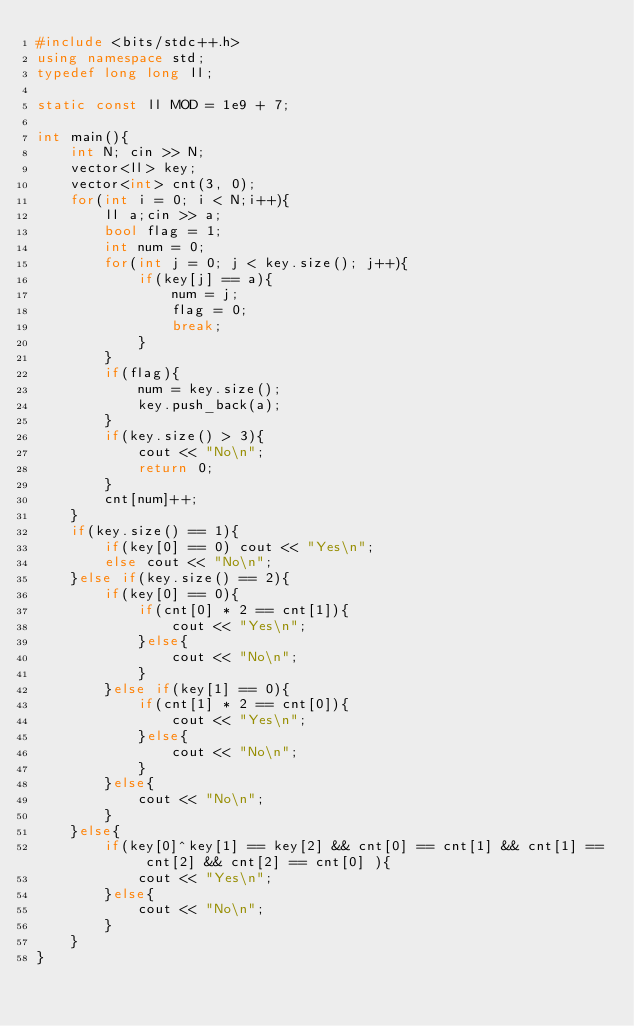<code> <loc_0><loc_0><loc_500><loc_500><_C++_>#include <bits/stdc++.h>
using namespace std;
typedef long long ll;

static const ll MOD = 1e9 + 7;

int main(){
    int N; cin >> N;
    vector<ll> key;
    vector<int> cnt(3, 0);
    for(int i = 0; i < N;i++){
        ll a;cin >> a;
        bool flag = 1;
        int num = 0;
        for(int j = 0; j < key.size(); j++){
            if(key[j] == a){
                num = j;
                flag = 0;
                break;
            }
        }
        if(flag){
            num = key.size();
            key.push_back(a);
        }
        if(key.size() > 3){
            cout << "No\n";
            return 0;
        }
        cnt[num]++;
    }
    if(key.size() == 1){
        if(key[0] == 0) cout << "Yes\n";
        else cout << "No\n";
    }else if(key.size() == 2){
        if(key[0] == 0){
            if(cnt[0] * 2 == cnt[1]){
                cout << "Yes\n";
            }else{
                cout << "No\n";
            }
        }else if(key[1] == 0){
            if(cnt[1] * 2 == cnt[0]){
                cout << "Yes\n";
            }else{
                cout << "No\n";
            }
        }else{
            cout << "No\n";
        }
    }else{
        if(key[0]^key[1] == key[2] && cnt[0] == cnt[1] && cnt[1] == cnt[2] && cnt[2] == cnt[0] ){
            cout << "Yes\n";
        }else{
            cout << "No\n";
        }
    }
}</code> 